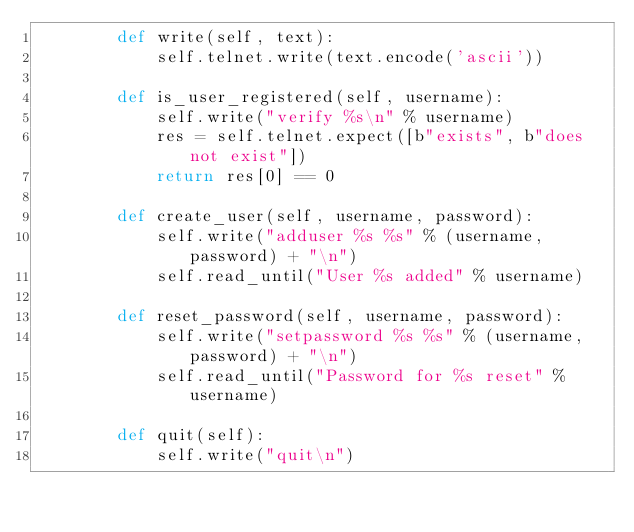<code> <loc_0><loc_0><loc_500><loc_500><_Python_>        def write(self, text):
            self.telnet.write(text.encode('ascii'))

        def is_user_registered(self, username):
            self.write("verify %s\n" % username)
            res = self.telnet.expect([b"exists", b"does not exist"])
            return res[0] == 0

        def create_user(self, username, password):
            self.write("adduser %s %s" % (username, password) + "\n")
            self.read_until("User %s added" % username)

        def reset_password(self, username, password):
            self.write("setpassword %s %s" % (username, password) + "\n")
            self.read_until("Password for %s reset" % username)

        def quit(self):
            self.write("quit\n")

</code> 